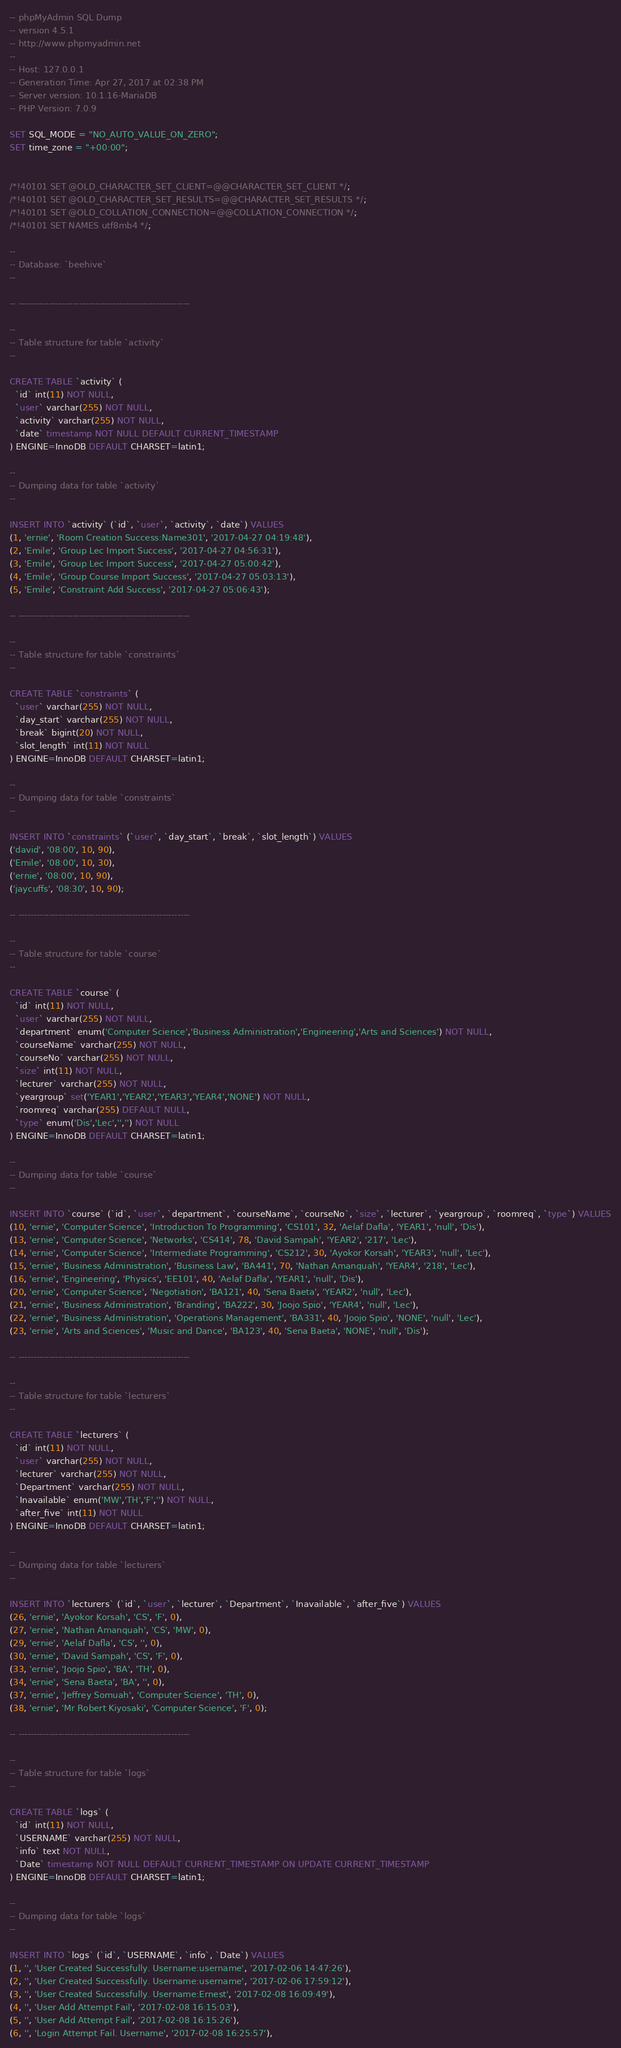Convert code to text. <code><loc_0><loc_0><loc_500><loc_500><_SQL_>-- phpMyAdmin SQL Dump
-- version 4.5.1
-- http://www.phpmyadmin.net
--
-- Host: 127.0.0.1
-- Generation Time: Apr 27, 2017 at 02:38 PM
-- Server version: 10.1.16-MariaDB
-- PHP Version: 7.0.9

SET SQL_MODE = "NO_AUTO_VALUE_ON_ZERO";
SET time_zone = "+00:00";


/*!40101 SET @OLD_CHARACTER_SET_CLIENT=@@CHARACTER_SET_CLIENT */;
/*!40101 SET @OLD_CHARACTER_SET_RESULTS=@@CHARACTER_SET_RESULTS */;
/*!40101 SET @OLD_COLLATION_CONNECTION=@@COLLATION_CONNECTION */;
/*!40101 SET NAMES utf8mb4 */;

--
-- Database: `beehive`
--

-- --------------------------------------------------------

--
-- Table structure for table `activity`
--

CREATE TABLE `activity` (
  `id` int(11) NOT NULL,
  `user` varchar(255) NOT NULL,
  `activity` varchar(255) NOT NULL,
  `date` timestamp NOT NULL DEFAULT CURRENT_TIMESTAMP
) ENGINE=InnoDB DEFAULT CHARSET=latin1;

--
-- Dumping data for table `activity`
--

INSERT INTO `activity` (`id`, `user`, `activity`, `date`) VALUES
(1, 'ernie', 'Room Creation Success:Name301', '2017-04-27 04:19:48'),
(2, 'Emile', 'Group Lec Import Success', '2017-04-27 04:56:31'),
(3, 'Emile', 'Group Lec Import Success', '2017-04-27 05:00:42'),
(4, 'Emile', 'Group Course Import Success', '2017-04-27 05:03:13'),
(5, 'Emile', 'Constraint Add Success', '2017-04-27 05:06:43');

-- --------------------------------------------------------

--
-- Table structure for table `constraints`
--

CREATE TABLE `constraints` (
  `user` varchar(255) NOT NULL,
  `day_start` varchar(255) NOT NULL,
  `break` bigint(20) NOT NULL,
  `slot_length` int(11) NOT NULL
) ENGINE=InnoDB DEFAULT CHARSET=latin1;

--
-- Dumping data for table `constraints`
--

INSERT INTO `constraints` (`user`, `day_start`, `break`, `slot_length`) VALUES
('david', '08:00', 10, 90),
('Emile', '08:00', 10, 30),
('ernie', '08:00', 10, 90),
('jaycuffs', '08:30', 10, 90);

-- --------------------------------------------------------

--
-- Table structure for table `course`
--

CREATE TABLE `course` (
  `id` int(11) NOT NULL,
  `user` varchar(255) NOT NULL,
  `department` enum('Computer Science','Business Administration','Engineering','Arts and Sciences') NOT NULL,
  `courseName` varchar(255) NOT NULL,
  `courseNo` varchar(255) NOT NULL,
  `size` int(11) NOT NULL,
  `lecturer` varchar(255) NOT NULL,
  `yeargroup` set('YEAR1','YEAR2','YEAR3','YEAR4','NONE') NOT NULL,
  `roomreq` varchar(255) DEFAULT NULL,
  `type` enum('Dis','Lec','','') NOT NULL
) ENGINE=InnoDB DEFAULT CHARSET=latin1;

--
-- Dumping data for table `course`
--

INSERT INTO `course` (`id`, `user`, `department`, `courseName`, `courseNo`, `size`, `lecturer`, `yeargroup`, `roomreq`, `type`) VALUES
(10, 'ernie', 'Computer Science', 'Introduction To Programming', 'CS101', 32, 'Aelaf Dafla', 'YEAR1', 'null', 'Dis'),
(13, 'ernie', 'Computer Science', 'Networks', 'CS414', 78, 'David Sampah', 'YEAR2', '217', 'Lec'),
(14, 'ernie', 'Computer Science', 'Intermediate Programming', 'CS212', 30, 'Ayokor Korsah', 'YEAR3', 'null', 'Lec'),
(15, 'ernie', 'Business Administration', 'Business Law', 'BA441', 70, 'Nathan Amanquah', 'YEAR4', '218', 'Lec'),
(16, 'ernie', 'Engineering', 'Physics', 'EE101', 40, 'Aelaf Dafla', 'YEAR1', 'null', 'Dis'),
(20, 'ernie', 'Computer Science', 'Negotiation', 'BA121', 40, 'Sena Baeta', 'YEAR2', 'null', 'Lec'),
(21, 'ernie', 'Business Administration', 'Branding', 'BA222', 30, 'Joojo Spio', 'YEAR4', 'null', 'Lec'),
(22, 'ernie', 'Business Administration', 'Operations Management', 'BA331', 40, 'Joojo Spio', 'NONE', 'null', 'Lec'),
(23, 'ernie', 'Arts and Sciences', 'Music and Dance', 'BA123', 40, 'Sena Baeta', 'NONE', 'null', 'Dis');

-- --------------------------------------------------------

--
-- Table structure for table `lecturers`
--

CREATE TABLE `lecturers` (
  `id` int(11) NOT NULL,
  `user` varchar(255) NOT NULL,
  `lecturer` varchar(255) NOT NULL,
  `Department` varchar(255) NOT NULL,
  `Inavailable` enum('MW','TH','F','') NOT NULL,
  `after_five` int(11) NOT NULL
) ENGINE=InnoDB DEFAULT CHARSET=latin1;

--
-- Dumping data for table `lecturers`
--

INSERT INTO `lecturers` (`id`, `user`, `lecturer`, `Department`, `Inavailable`, `after_five`) VALUES
(26, 'ernie', 'Ayokor Korsah', 'CS', 'F', 0),
(27, 'ernie', 'Nathan Amanquah', 'CS', 'MW', 0),
(29, 'ernie', 'Aelaf Dafla', 'CS', '', 0),
(30, 'ernie', 'David Sampah', 'CS', 'F', 0),
(33, 'ernie', 'Joojo Spio', 'BA', 'TH', 0),
(34, 'ernie', 'Sena Baeta', 'BA', '', 0),
(37, 'ernie', 'Jeffrey Somuah', 'Computer Science', 'TH', 0),
(38, 'ernie', 'Mr Robert Kiyosaki', 'Computer Science', 'F', 0);

-- --------------------------------------------------------

--
-- Table structure for table `logs`
--

CREATE TABLE `logs` (
  `id` int(11) NOT NULL,
  `USERNAME` varchar(255) NOT NULL,
  `info` text NOT NULL,
  `Date` timestamp NOT NULL DEFAULT CURRENT_TIMESTAMP ON UPDATE CURRENT_TIMESTAMP
) ENGINE=InnoDB DEFAULT CHARSET=latin1;

--
-- Dumping data for table `logs`
--

INSERT INTO `logs` (`id`, `USERNAME`, `info`, `Date`) VALUES
(1, '', 'User Created Successfully. Username:username', '2017-02-06 14:47:26'),
(2, '', 'User Created Successfully. Username:username', '2017-02-06 17:59:12'),
(3, '', 'User Created Successfully. Username:Ernest', '2017-02-08 16:09:49'),
(4, '', 'User Add Attempt Fail', '2017-02-08 16:15:03'),
(5, '', 'User Add Attempt Fail', '2017-02-08 16:15:26'),
(6, '', 'Login Attempt Fail. Username', '2017-02-08 16:25:57'),</code> 